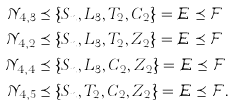Convert formula to latex. <formula><loc_0><loc_0><loc_500><loc_500>\mathcal { N } _ { 4 , 3 } & \preceq \{ S _ { n } , L _ { 3 } , T _ { 2 } , C _ { 2 } \} = \mathcal { E \preceq \mathcal { F } } \\ \mathcal { N } _ { 4 , 2 } & \preceq \{ S _ { n } , L _ { 3 } , T _ { 2 } , Z _ { 2 } \} = \mathcal { E \preceq \mathcal { F } } \\ \mathcal { N } _ { 4 , 4 } & \preceq \{ S _ { n } , L _ { 3 } , C _ { 2 } , Z _ { 2 } \} = \mathcal { E \preceq \mathcal { F } } \\ \mathcal { N } _ { 4 , 5 } & \preceq \{ S _ { n } , T _ { 2 } , C _ { 2 } , Z _ { 2 } \} = \mathcal { E \preceq \mathcal { F } } .</formula> 